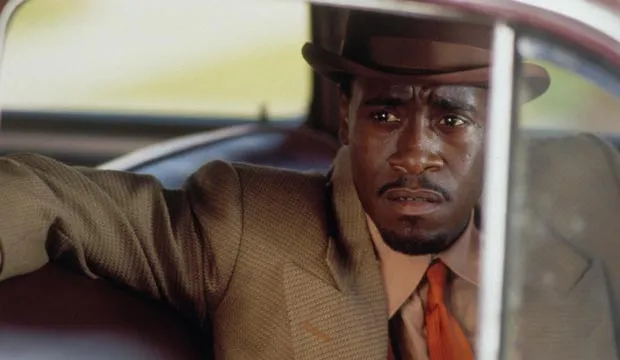Imagine this scene is from a dream. What happens next? In the dream, the detective’s serious expression suddenly shifts as he notices something unusual through the car window. The cityscape outside begins to warp and twist, transforming into a surreal, nightmarish version of itself. Buildings stretch and contort, while shadows flicker and dance in impossible patterns. The detective steps out of the car, finding himself in an eerie, fog-shrouded street. His footsteps echo unnaturally, and disembodied whispers fill the air. As he ventures further, he encounters figures from his past cases, their faces distorted and cryptic messages on their lips. The detective must navigate this haunting dreamscape, piecing together fragments of his subconscious to uncover a hidden truth buried deep within his mind. This journey through the maze of memories and fears challenges his perception of reality, blurring the lines between dream and wakefulness. 